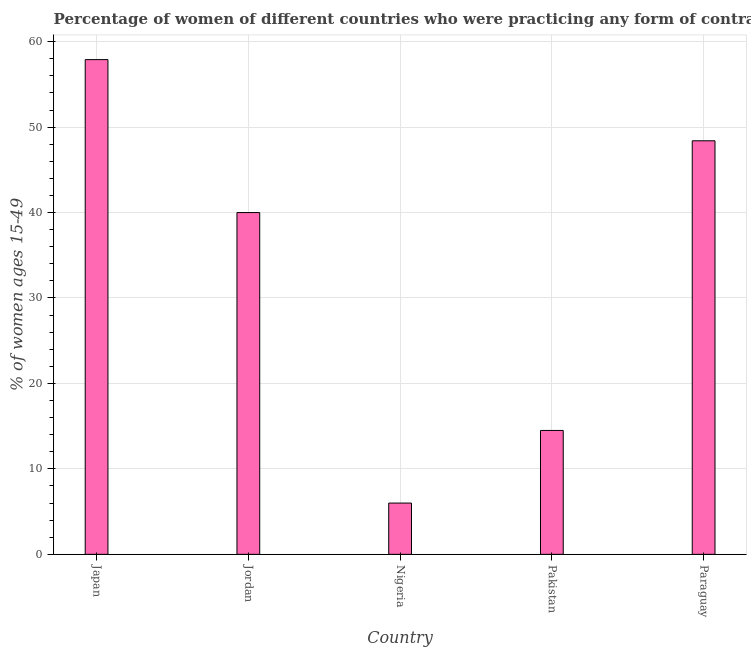Does the graph contain any zero values?
Offer a terse response. No. Does the graph contain grids?
Provide a succinct answer. Yes. What is the title of the graph?
Ensure brevity in your answer.  Percentage of women of different countries who were practicing any form of contraception in 1990. What is the label or title of the X-axis?
Your answer should be very brief. Country. What is the label or title of the Y-axis?
Keep it short and to the point. % of women ages 15-49. What is the contraceptive prevalence in Japan?
Offer a very short reply. 57.9. Across all countries, what is the maximum contraceptive prevalence?
Your response must be concise. 57.9. Across all countries, what is the minimum contraceptive prevalence?
Your response must be concise. 6. In which country was the contraceptive prevalence maximum?
Provide a succinct answer. Japan. In which country was the contraceptive prevalence minimum?
Your answer should be compact. Nigeria. What is the sum of the contraceptive prevalence?
Give a very brief answer. 166.8. What is the difference between the contraceptive prevalence in Pakistan and Paraguay?
Your answer should be compact. -33.9. What is the average contraceptive prevalence per country?
Your answer should be very brief. 33.36. What is the median contraceptive prevalence?
Provide a succinct answer. 40. In how many countries, is the contraceptive prevalence greater than 44 %?
Keep it short and to the point. 2. What is the ratio of the contraceptive prevalence in Jordan to that in Paraguay?
Keep it short and to the point. 0.83. Is the contraceptive prevalence in Nigeria less than that in Pakistan?
Your answer should be compact. Yes. Is the difference between the contraceptive prevalence in Japan and Jordan greater than the difference between any two countries?
Your response must be concise. No. What is the difference between the highest and the second highest contraceptive prevalence?
Offer a very short reply. 9.5. What is the difference between the highest and the lowest contraceptive prevalence?
Your response must be concise. 51.9. In how many countries, is the contraceptive prevalence greater than the average contraceptive prevalence taken over all countries?
Provide a succinct answer. 3. How many bars are there?
Make the answer very short. 5. Are all the bars in the graph horizontal?
Your response must be concise. No. What is the difference between two consecutive major ticks on the Y-axis?
Provide a short and direct response. 10. What is the % of women ages 15-49 in Japan?
Ensure brevity in your answer.  57.9. What is the % of women ages 15-49 in Jordan?
Your answer should be very brief. 40. What is the % of women ages 15-49 in Nigeria?
Give a very brief answer. 6. What is the % of women ages 15-49 of Pakistan?
Ensure brevity in your answer.  14.5. What is the % of women ages 15-49 in Paraguay?
Provide a short and direct response. 48.4. What is the difference between the % of women ages 15-49 in Japan and Jordan?
Your response must be concise. 17.9. What is the difference between the % of women ages 15-49 in Japan and Nigeria?
Your response must be concise. 51.9. What is the difference between the % of women ages 15-49 in Japan and Pakistan?
Make the answer very short. 43.4. What is the difference between the % of women ages 15-49 in Japan and Paraguay?
Ensure brevity in your answer.  9.5. What is the difference between the % of women ages 15-49 in Jordan and Pakistan?
Offer a terse response. 25.5. What is the difference between the % of women ages 15-49 in Jordan and Paraguay?
Provide a short and direct response. -8.4. What is the difference between the % of women ages 15-49 in Nigeria and Pakistan?
Provide a short and direct response. -8.5. What is the difference between the % of women ages 15-49 in Nigeria and Paraguay?
Ensure brevity in your answer.  -42.4. What is the difference between the % of women ages 15-49 in Pakistan and Paraguay?
Provide a succinct answer. -33.9. What is the ratio of the % of women ages 15-49 in Japan to that in Jordan?
Make the answer very short. 1.45. What is the ratio of the % of women ages 15-49 in Japan to that in Nigeria?
Give a very brief answer. 9.65. What is the ratio of the % of women ages 15-49 in Japan to that in Pakistan?
Make the answer very short. 3.99. What is the ratio of the % of women ages 15-49 in Japan to that in Paraguay?
Provide a succinct answer. 1.2. What is the ratio of the % of women ages 15-49 in Jordan to that in Nigeria?
Give a very brief answer. 6.67. What is the ratio of the % of women ages 15-49 in Jordan to that in Pakistan?
Keep it short and to the point. 2.76. What is the ratio of the % of women ages 15-49 in Jordan to that in Paraguay?
Offer a terse response. 0.83. What is the ratio of the % of women ages 15-49 in Nigeria to that in Pakistan?
Ensure brevity in your answer.  0.41. What is the ratio of the % of women ages 15-49 in Nigeria to that in Paraguay?
Offer a terse response. 0.12. What is the ratio of the % of women ages 15-49 in Pakistan to that in Paraguay?
Your response must be concise. 0.3. 